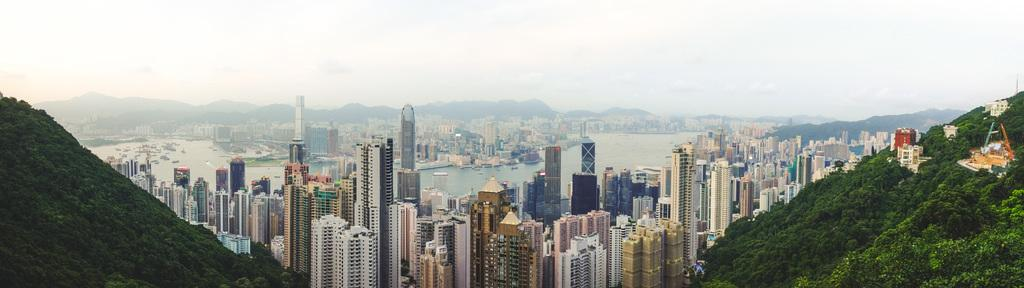What type of view is shown in the image? The image is an aerial view. What structures can be seen from this perspective? There are buildings visible in the image. What natural elements are present in the image? Greenery, water, and mountains are visible in the image. What else can be seen in the image? The sky is visible in the image. Can you see the governor's crown in the image? There is no governor or crown present in the image. Are there any jellyfish visible in the water shown in the image? There is no indication of jellyfish in the water visible in the image. 